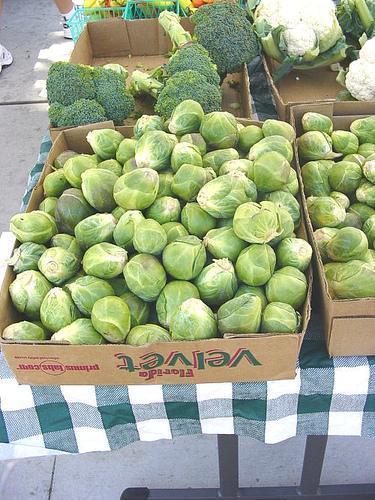How many broccolis are there?
Give a very brief answer. 3. How many dining tables can be seen?
Give a very brief answer. 1. 